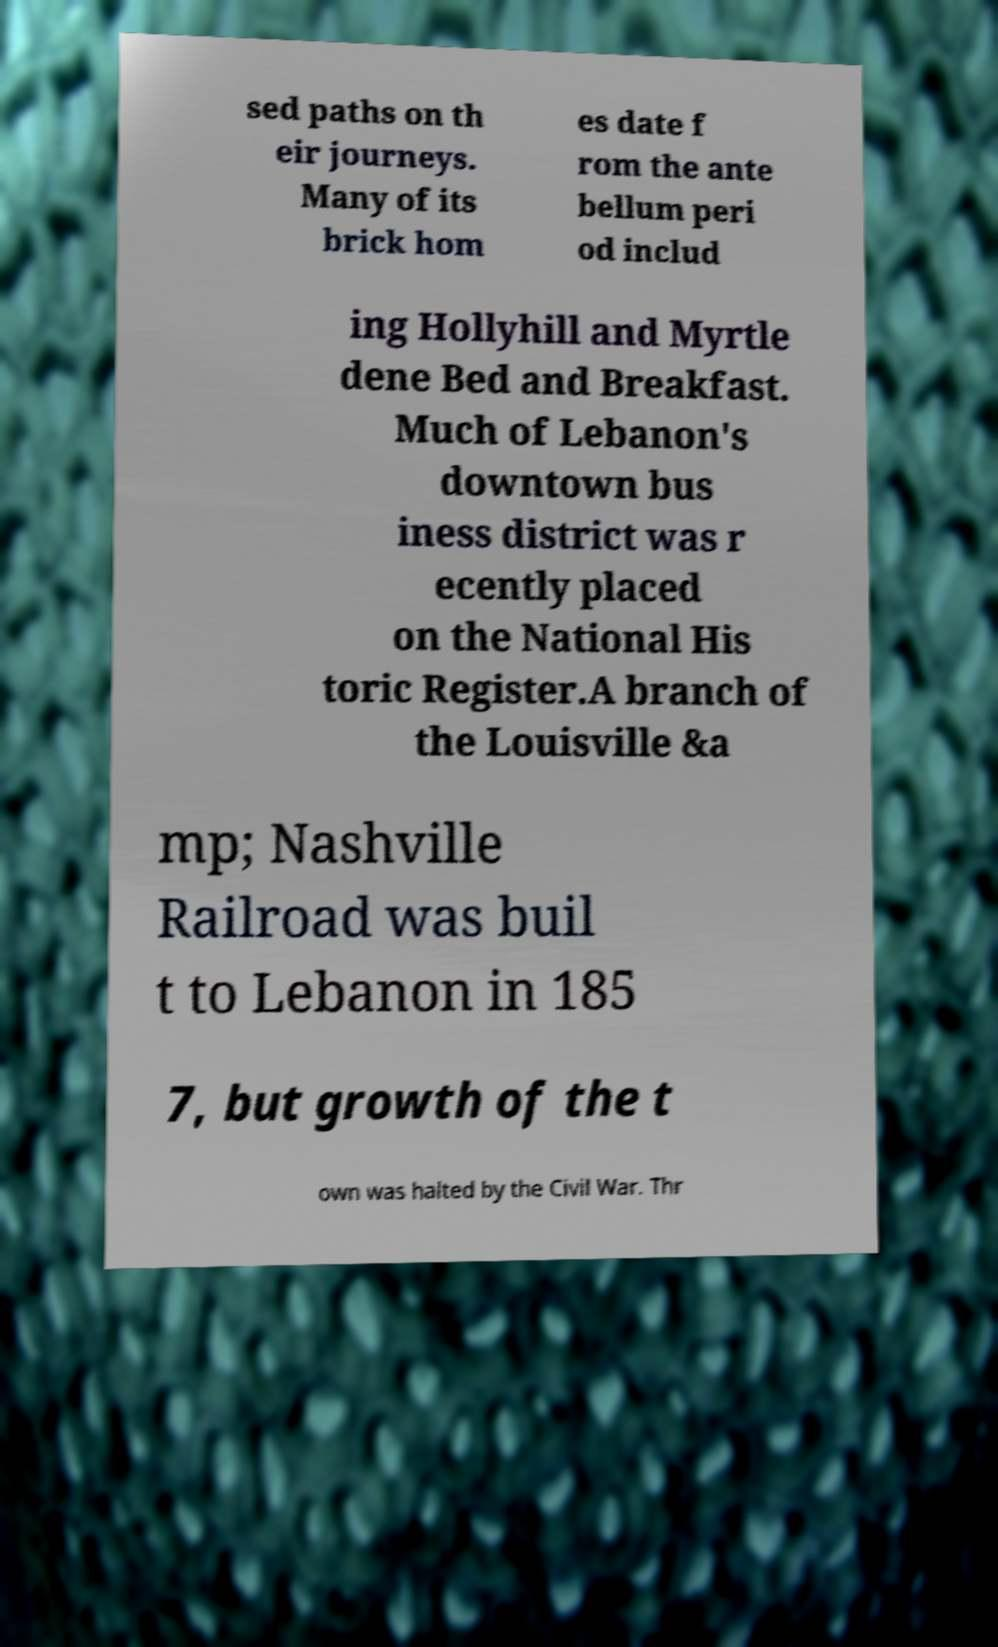Can you accurately transcribe the text from the provided image for me? sed paths on th eir journeys. Many of its brick hom es date f rom the ante bellum peri od includ ing Hollyhill and Myrtle dene Bed and Breakfast. Much of Lebanon's downtown bus iness district was r ecently placed on the National His toric Register.A branch of the Louisville &a mp; Nashville Railroad was buil t to Lebanon in 185 7, but growth of the t own was halted by the Civil War. Thr 